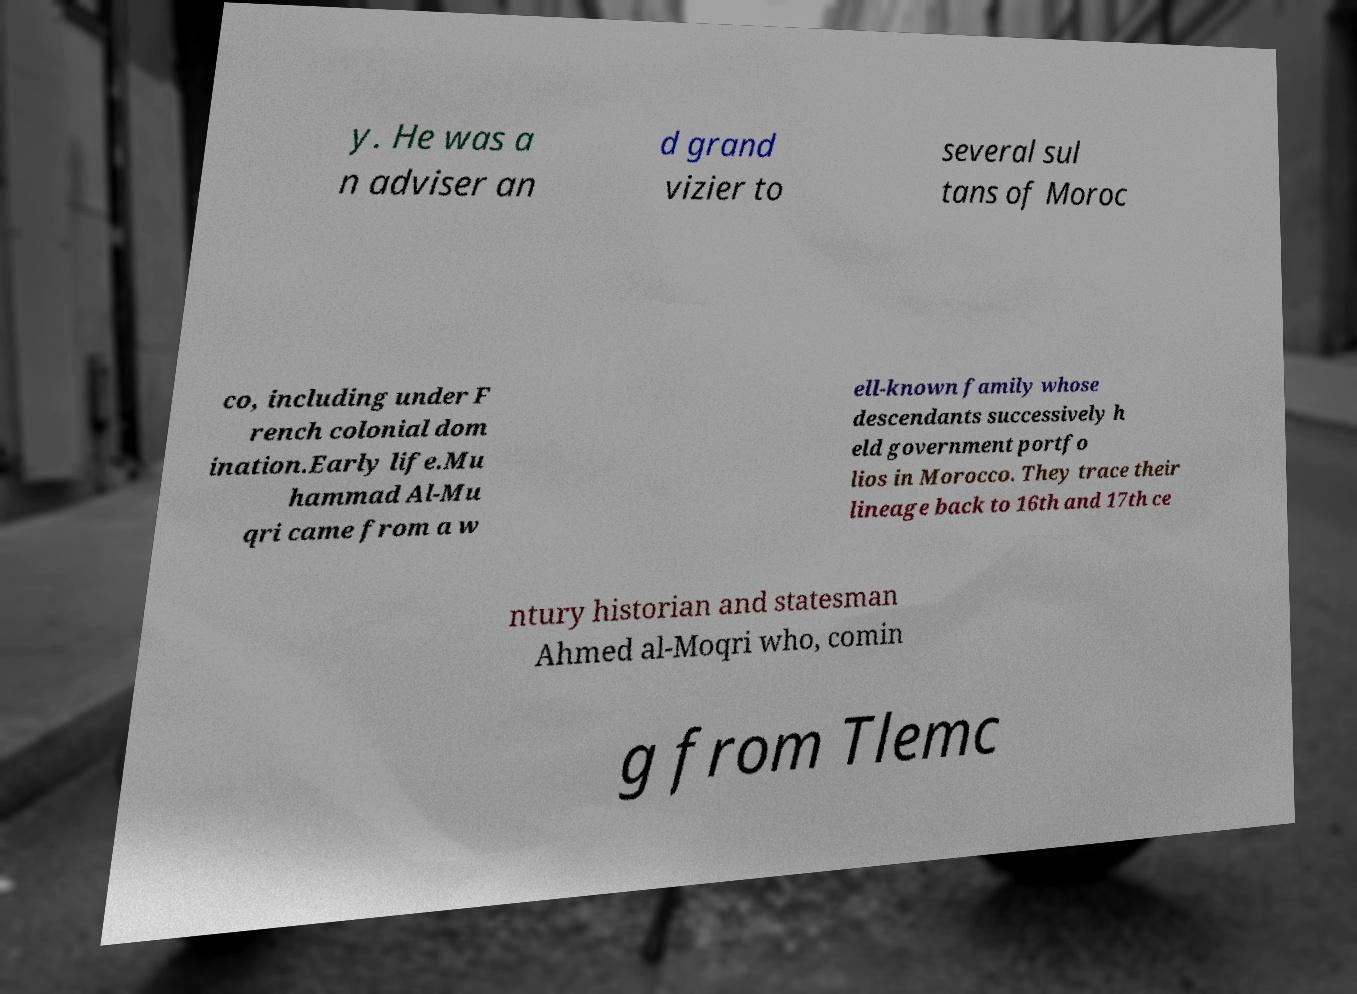Can you accurately transcribe the text from the provided image for me? y. He was a n adviser an d grand vizier to several sul tans of Moroc co, including under F rench colonial dom ination.Early life.Mu hammad Al-Mu qri came from a w ell-known family whose descendants successively h eld government portfo lios in Morocco. They trace their lineage back to 16th and 17th ce ntury historian and statesman Ahmed al-Moqri who, comin g from Tlemc 